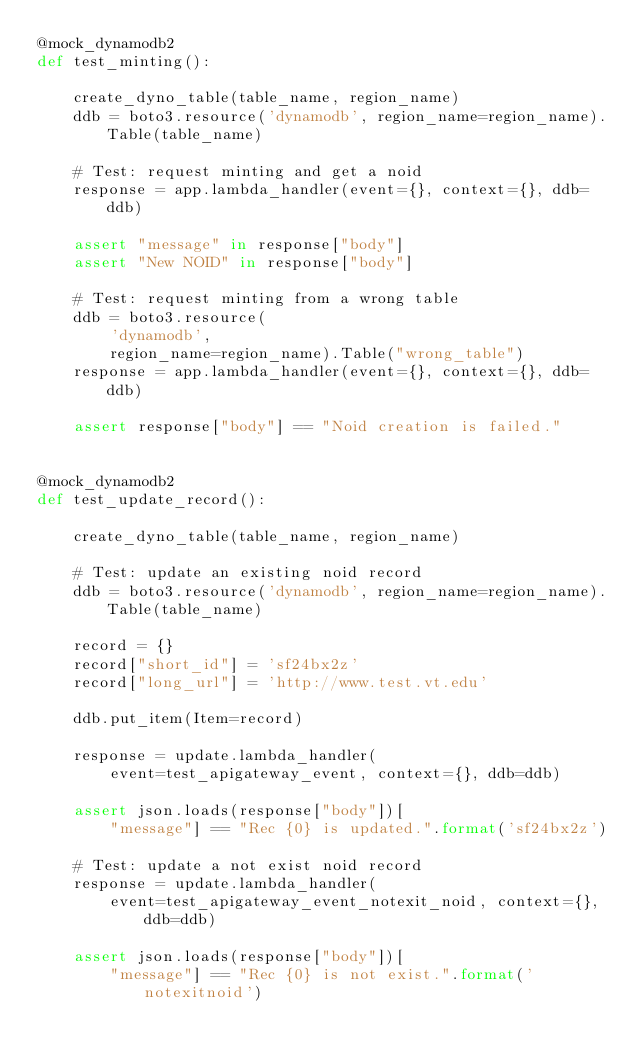<code> <loc_0><loc_0><loc_500><loc_500><_Python_>@mock_dynamodb2
def test_minting():

    create_dyno_table(table_name, region_name)
    ddb = boto3.resource('dynamodb', region_name=region_name).Table(table_name)

    # Test: request minting and get a noid
    response = app.lambda_handler(event={}, context={}, ddb=ddb)

    assert "message" in response["body"]
    assert "New NOID" in response["body"]

    # Test: request minting from a wrong table
    ddb = boto3.resource(
        'dynamodb',
        region_name=region_name).Table("wrong_table")
    response = app.lambda_handler(event={}, context={}, ddb=ddb)

    assert response["body"] == "Noid creation is failed."


@mock_dynamodb2
def test_update_record():

    create_dyno_table(table_name, region_name)

    # Test: update an existing noid record
    ddb = boto3.resource('dynamodb', region_name=region_name).Table(table_name)

    record = {}
    record["short_id"] = 'sf24bx2z'
    record["long_url"] = 'http://www.test.vt.edu'

    ddb.put_item(Item=record)

    response = update.lambda_handler(
        event=test_apigateway_event, context={}, ddb=ddb)

    assert json.loads(response["body"])[
        "message"] == "Rec {0} is updated.".format('sf24bx2z')

    # Test: update a not exist noid record
    response = update.lambda_handler(
        event=test_apigateway_event_notexit_noid, context={}, ddb=ddb)

    assert json.loads(response["body"])[
        "message"] == "Rec {0} is not exist.".format('notexitnoid')
</code> 